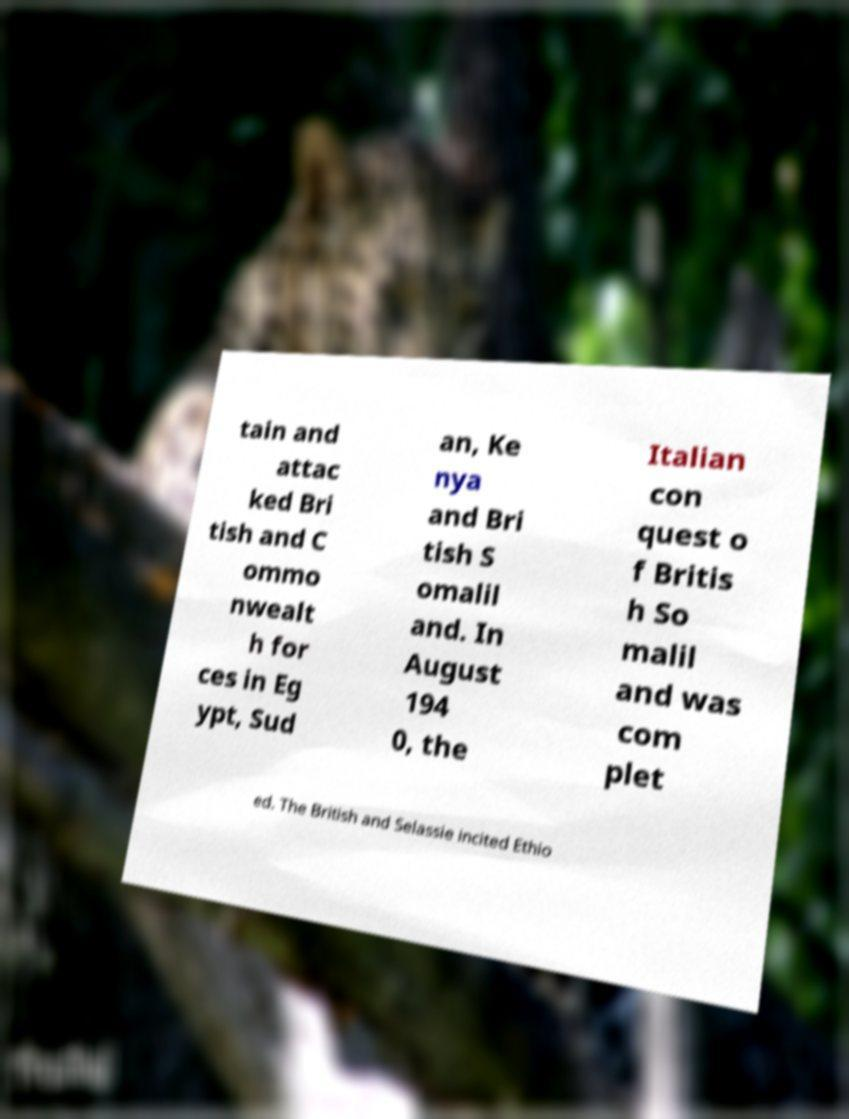For documentation purposes, I need the text within this image transcribed. Could you provide that? tain and attac ked Bri tish and C ommo nwealt h for ces in Eg ypt, Sud an, Ke nya and Bri tish S omalil and. In August 194 0, the Italian con quest o f Britis h So malil and was com plet ed. The British and Selassie incited Ethio 